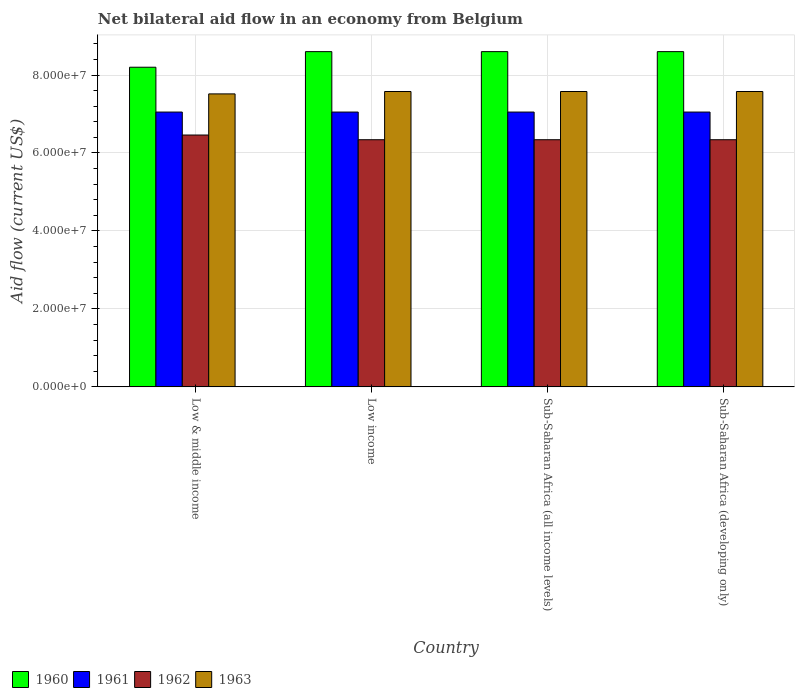Are the number of bars per tick equal to the number of legend labels?
Offer a terse response. Yes. How many bars are there on the 1st tick from the left?
Your answer should be compact. 4. What is the label of the 2nd group of bars from the left?
Keep it short and to the point. Low income. What is the net bilateral aid flow in 1962 in Sub-Saharan Africa (developing only)?
Provide a succinct answer. 6.34e+07. Across all countries, what is the maximum net bilateral aid flow in 1963?
Provide a short and direct response. 7.58e+07. Across all countries, what is the minimum net bilateral aid flow in 1963?
Offer a very short reply. 7.52e+07. What is the total net bilateral aid flow in 1963 in the graph?
Provide a succinct answer. 3.02e+08. What is the difference between the net bilateral aid flow in 1961 in Low & middle income and that in Sub-Saharan Africa (developing only)?
Provide a succinct answer. 0. What is the difference between the net bilateral aid flow in 1963 in Low income and the net bilateral aid flow in 1962 in Low & middle income?
Ensure brevity in your answer.  1.12e+07. What is the average net bilateral aid flow in 1960 per country?
Keep it short and to the point. 8.50e+07. What is the difference between the net bilateral aid flow of/in 1960 and net bilateral aid flow of/in 1961 in Sub-Saharan Africa (developing only)?
Give a very brief answer. 1.55e+07. In how many countries, is the net bilateral aid flow in 1963 greater than 68000000 US$?
Your answer should be very brief. 4. What is the ratio of the net bilateral aid flow in 1963 in Sub-Saharan Africa (all income levels) to that in Sub-Saharan Africa (developing only)?
Give a very brief answer. 1. Is the net bilateral aid flow in 1960 in Sub-Saharan Africa (all income levels) less than that in Sub-Saharan Africa (developing only)?
Your answer should be compact. No. What is the difference between the highest and the second highest net bilateral aid flow in 1962?
Your answer should be very brief. 1.21e+06. What is the difference between the highest and the lowest net bilateral aid flow in 1963?
Your response must be concise. 6.10e+05. In how many countries, is the net bilateral aid flow in 1962 greater than the average net bilateral aid flow in 1962 taken over all countries?
Offer a very short reply. 1. Is it the case that in every country, the sum of the net bilateral aid flow in 1962 and net bilateral aid flow in 1963 is greater than the sum of net bilateral aid flow in 1960 and net bilateral aid flow in 1961?
Keep it short and to the point. No. What does the 1st bar from the left in Low income represents?
Offer a very short reply. 1960. What does the 2nd bar from the right in Low & middle income represents?
Your response must be concise. 1962. How many bars are there?
Offer a very short reply. 16. Are all the bars in the graph horizontal?
Your response must be concise. No. What is the difference between two consecutive major ticks on the Y-axis?
Provide a short and direct response. 2.00e+07. Where does the legend appear in the graph?
Provide a succinct answer. Bottom left. What is the title of the graph?
Provide a succinct answer. Net bilateral aid flow in an economy from Belgium. What is the label or title of the X-axis?
Give a very brief answer. Country. What is the label or title of the Y-axis?
Ensure brevity in your answer.  Aid flow (current US$). What is the Aid flow (current US$) in 1960 in Low & middle income?
Your answer should be very brief. 8.20e+07. What is the Aid flow (current US$) of 1961 in Low & middle income?
Your answer should be compact. 7.05e+07. What is the Aid flow (current US$) of 1962 in Low & middle income?
Your answer should be very brief. 6.46e+07. What is the Aid flow (current US$) of 1963 in Low & middle income?
Ensure brevity in your answer.  7.52e+07. What is the Aid flow (current US$) in 1960 in Low income?
Your answer should be compact. 8.60e+07. What is the Aid flow (current US$) of 1961 in Low income?
Offer a terse response. 7.05e+07. What is the Aid flow (current US$) in 1962 in Low income?
Your answer should be compact. 6.34e+07. What is the Aid flow (current US$) of 1963 in Low income?
Provide a succinct answer. 7.58e+07. What is the Aid flow (current US$) in 1960 in Sub-Saharan Africa (all income levels)?
Keep it short and to the point. 8.60e+07. What is the Aid flow (current US$) in 1961 in Sub-Saharan Africa (all income levels)?
Keep it short and to the point. 7.05e+07. What is the Aid flow (current US$) in 1962 in Sub-Saharan Africa (all income levels)?
Your response must be concise. 6.34e+07. What is the Aid flow (current US$) of 1963 in Sub-Saharan Africa (all income levels)?
Offer a terse response. 7.58e+07. What is the Aid flow (current US$) in 1960 in Sub-Saharan Africa (developing only)?
Your response must be concise. 8.60e+07. What is the Aid flow (current US$) in 1961 in Sub-Saharan Africa (developing only)?
Your answer should be very brief. 7.05e+07. What is the Aid flow (current US$) of 1962 in Sub-Saharan Africa (developing only)?
Your answer should be very brief. 6.34e+07. What is the Aid flow (current US$) of 1963 in Sub-Saharan Africa (developing only)?
Make the answer very short. 7.58e+07. Across all countries, what is the maximum Aid flow (current US$) of 1960?
Keep it short and to the point. 8.60e+07. Across all countries, what is the maximum Aid flow (current US$) in 1961?
Offer a terse response. 7.05e+07. Across all countries, what is the maximum Aid flow (current US$) in 1962?
Your answer should be very brief. 6.46e+07. Across all countries, what is the maximum Aid flow (current US$) of 1963?
Your response must be concise. 7.58e+07. Across all countries, what is the minimum Aid flow (current US$) in 1960?
Make the answer very short. 8.20e+07. Across all countries, what is the minimum Aid flow (current US$) of 1961?
Offer a very short reply. 7.05e+07. Across all countries, what is the minimum Aid flow (current US$) in 1962?
Keep it short and to the point. 6.34e+07. Across all countries, what is the minimum Aid flow (current US$) in 1963?
Your response must be concise. 7.52e+07. What is the total Aid flow (current US$) of 1960 in the graph?
Give a very brief answer. 3.40e+08. What is the total Aid flow (current US$) of 1961 in the graph?
Ensure brevity in your answer.  2.82e+08. What is the total Aid flow (current US$) in 1962 in the graph?
Provide a succinct answer. 2.55e+08. What is the total Aid flow (current US$) of 1963 in the graph?
Ensure brevity in your answer.  3.02e+08. What is the difference between the Aid flow (current US$) in 1960 in Low & middle income and that in Low income?
Your answer should be very brief. -4.00e+06. What is the difference between the Aid flow (current US$) in 1961 in Low & middle income and that in Low income?
Keep it short and to the point. 0. What is the difference between the Aid flow (current US$) of 1962 in Low & middle income and that in Low income?
Provide a short and direct response. 1.21e+06. What is the difference between the Aid flow (current US$) of 1963 in Low & middle income and that in Low income?
Provide a succinct answer. -6.10e+05. What is the difference between the Aid flow (current US$) of 1960 in Low & middle income and that in Sub-Saharan Africa (all income levels)?
Your response must be concise. -4.00e+06. What is the difference between the Aid flow (current US$) in 1962 in Low & middle income and that in Sub-Saharan Africa (all income levels)?
Make the answer very short. 1.21e+06. What is the difference between the Aid flow (current US$) of 1963 in Low & middle income and that in Sub-Saharan Africa (all income levels)?
Offer a very short reply. -6.10e+05. What is the difference between the Aid flow (current US$) in 1962 in Low & middle income and that in Sub-Saharan Africa (developing only)?
Your response must be concise. 1.21e+06. What is the difference between the Aid flow (current US$) in 1963 in Low & middle income and that in Sub-Saharan Africa (developing only)?
Ensure brevity in your answer.  -6.10e+05. What is the difference between the Aid flow (current US$) in 1960 in Low income and that in Sub-Saharan Africa (all income levels)?
Your response must be concise. 0. What is the difference between the Aid flow (current US$) in 1963 in Low income and that in Sub-Saharan Africa (all income levels)?
Your answer should be compact. 0. What is the difference between the Aid flow (current US$) of 1960 in Low income and that in Sub-Saharan Africa (developing only)?
Keep it short and to the point. 0. What is the difference between the Aid flow (current US$) in 1961 in Low income and that in Sub-Saharan Africa (developing only)?
Make the answer very short. 0. What is the difference between the Aid flow (current US$) of 1961 in Sub-Saharan Africa (all income levels) and that in Sub-Saharan Africa (developing only)?
Offer a very short reply. 0. What is the difference between the Aid flow (current US$) in 1960 in Low & middle income and the Aid flow (current US$) in 1961 in Low income?
Your answer should be very brief. 1.15e+07. What is the difference between the Aid flow (current US$) in 1960 in Low & middle income and the Aid flow (current US$) in 1962 in Low income?
Your answer should be very brief. 1.86e+07. What is the difference between the Aid flow (current US$) of 1960 in Low & middle income and the Aid flow (current US$) of 1963 in Low income?
Offer a terse response. 6.23e+06. What is the difference between the Aid flow (current US$) of 1961 in Low & middle income and the Aid flow (current US$) of 1962 in Low income?
Provide a succinct answer. 7.10e+06. What is the difference between the Aid flow (current US$) in 1961 in Low & middle income and the Aid flow (current US$) in 1963 in Low income?
Your answer should be compact. -5.27e+06. What is the difference between the Aid flow (current US$) of 1962 in Low & middle income and the Aid flow (current US$) of 1963 in Low income?
Your answer should be very brief. -1.12e+07. What is the difference between the Aid flow (current US$) in 1960 in Low & middle income and the Aid flow (current US$) in 1961 in Sub-Saharan Africa (all income levels)?
Make the answer very short. 1.15e+07. What is the difference between the Aid flow (current US$) in 1960 in Low & middle income and the Aid flow (current US$) in 1962 in Sub-Saharan Africa (all income levels)?
Make the answer very short. 1.86e+07. What is the difference between the Aid flow (current US$) in 1960 in Low & middle income and the Aid flow (current US$) in 1963 in Sub-Saharan Africa (all income levels)?
Offer a very short reply. 6.23e+06. What is the difference between the Aid flow (current US$) of 1961 in Low & middle income and the Aid flow (current US$) of 1962 in Sub-Saharan Africa (all income levels)?
Your response must be concise. 7.10e+06. What is the difference between the Aid flow (current US$) in 1961 in Low & middle income and the Aid flow (current US$) in 1963 in Sub-Saharan Africa (all income levels)?
Keep it short and to the point. -5.27e+06. What is the difference between the Aid flow (current US$) in 1962 in Low & middle income and the Aid flow (current US$) in 1963 in Sub-Saharan Africa (all income levels)?
Offer a very short reply. -1.12e+07. What is the difference between the Aid flow (current US$) of 1960 in Low & middle income and the Aid flow (current US$) of 1961 in Sub-Saharan Africa (developing only)?
Your answer should be very brief. 1.15e+07. What is the difference between the Aid flow (current US$) in 1960 in Low & middle income and the Aid flow (current US$) in 1962 in Sub-Saharan Africa (developing only)?
Provide a short and direct response. 1.86e+07. What is the difference between the Aid flow (current US$) of 1960 in Low & middle income and the Aid flow (current US$) of 1963 in Sub-Saharan Africa (developing only)?
Give a very brief answer. 6.23e+06. What is the difference between the Aid flow (current US$) of 1961 in Low & middle income and the Aid flow (current US$) of 1962 in Sub-Saharan Africa (developing only)?
Give a very brief answer. 7.10e+06. What is the difference between the Aid flow (current US$) in 1961 in Low & middle income and the Aid flow (current US$) in 1963 in Sub-Saharan Africa (developing only)?
Offer a very short reply. -5.27e+06. What is the difference between the Aid flow (current US$) of 1962 in Low & middle income and the Aid flow (current US$) of 1963 in Sub-Saharan Africa (developing only)?
Offer a terse response. -1.12e+07. What is the difference between the Aid flow (current US$) in 1960 in Low income and the Aid flow (current US$) in 1961 in Sub-Saharan Africa (all income levels)?
Make the answer very short. 1.55e+07. What is the difference between the Aid flow (current US$) in 1960 in Low income and the Aid flow (current US$) in 1962 in Sub-Saharan Africa (all income levels)?
Provide a succinct answer. 2.26e+07. What is the difference between the Aid flow (current US$) of 1960 in Low income and the Aid flow (current US$) of 1963 in Sub-Saharan Africa (all income levels)?
Provide a succinct answer. 1.02e+07. What is the difference between the Aid flow (current US$) in 1961 in Low income and the Aid flow (current US$) in 1962 in Sub-Saharan Africa (all income levels)?
Offer a terse response. 7.10e+06. What is the difference between the Aid flow (current US$) of 1961 in Low income and the Aid flow (current US$) of 1963 in Sub-Saharan Africa (all income levels)?
Make the answer very short. -5.27e+06. What is the difference between the Aid flow (current US$) in 1962 in Low income and the Aid flow (current US$) in 1963 in Sub-Saharan Africa (all income levels)?
Your response must be concise. -1.24e+07. What is the difference between the Aid flow (current US$) of 1960 in Low income and the Aid flow (current US$) of 1961 in Sub-Saharan Africa (developing only)?
Make the answer very short. 1.55e+07. What is the difference between the Aid flow (current US$) in 1960 in Low income and the Aid flow (current US$) in 1962 in Sub-Saharan Africa (developing only)?
Your response must be concise. 2.26e+07. What is the difference between the Aid flow (current US$) in 1960 in Low income and the Aid flow (current US$) in 1963 in Sub-Saharan Africa (developing only)?
Provide a succinct answer. 1.02e+07. What is the difference between the Aid flow (current US$) of 1961 in Low income and the Aid flow (current US$) of 1962 in Sub-Saharan Africa (developing only)?
Offer a very short reply. 7.10e+06. What is the difference between the Aid flow (current US$) of 1961 in Low income and the Aid flow (current US$) of 1963 in Sub-Saharan Africa (developing only)?
Your answer should be very brief. -5.27e+06. What is the difference between the Aid flow (current US$) of 1962 in Low income and the Aid flow (current US$) of 1963 in Sub-Saharan Africa (developing only)?
Your answer should be compact. -1.24e+07. What is the difference between the Aid flow (current US$) of 1960 in Sub-Saharan Africa (all income levels) and the Aid flow (current US$) of 1961 in Sub-Saharan Africa (developing only)?
Provide a short and direct response. 1.55e+07. What is the difference between the Aid flow (current US$) of 1960 in Sub-Saharan Africa (all income levels) and the Aid flow (current US$) of 1962 in Sub-Saharan Africa (developing only)?
Give a very brief answer. 2.26e+07. What is the difference between the Aid flow (current US$) of 1960 in Sub-Saharan Africa (all income levels) and the Aid flow (current US$) of 1963 in Sub-Saharan Africa (developing only)?
Make the answer very short. 1.02e+07. What is the difference between the Aid flow (current US$) of 1961 in Sub-Saharan Africa (all income levels) and the Aid flow (current US$) of 1962 in Sub-Saharan Africa (developing only)?
Your response must be concise. 7.10e+06. What is the difference between the Aid flow (current US$) in 1961 in Sub-Saharan Africa (all income levels) and the Aid flow (current US$) in 1963 in Sub-Saharan Africa (developing only)?
Keep it short and to the point. -5.27e+06. What is the difference between the Aid flow (current US$) of 1962 in Sub-Saharan Africa (all income levels) and the Aid flow (current US$) of 1963 in Sub-Saharan Africa (developing only)?
Your answer should be compact. -1.24e+07. What is the average Aid flow (current US$) in 1960 per country?
Your response must be concise. 8.50e+07. What is the average Aid flow (current US$) of 1961 per country?
Offer a terse response. 7.05e+07. What is the average Aid flow (current US$) in 1962 per country?
Provide a short and direct response. 6.37e+07. What is the average Aid flow (current US$) in 1963 per country?
Give a very brief answer. 7.56e+07. What is the difference between the Aid flow (current US$) in 1960 and Aid flow (current US$) in 1961 in Low & middle income?
Ensure brevity in your answer.  1.15e+07. What is the difference between the Aid flow (current US$) in 1960 and Aid flow (current US$) in 1962 in Low & middle income?
Ensure brevity in your answer.  1.74e+07. What is the difference between the Aid flow (current US$) in 1960 and Aid flow (current US$) in 1963 in Low & middle income?
Keep it short and to the point. 6.84e+06. What is the difference between the Aid flow (current US$) of 1961 and Aid flow (current US$) of 1962 in Low & middle income?
Give a very brief answer. 5.89e+06. What is the difference between the Aid flow (current US$) of 1961 and Aid flow (current US$) of 1963 in Low & middle income?
Ensure brevity in your answer.  -4.66e+06. What is the difference between the Aid flow (current US$) of 1962 and Aid flow (current US$) of 1963 in Low & middle income?
Offer a very short reply. -1.06e+07. What is the difference between the Aid flow (current US$) in 1960 and Aid flow (current US$) in 1961 in Low income?
Make the answer very short. 1.55e+07. What is the difference between the Aid flow (current US$) in 1960 and Aid flow (current US$) in 1962 in Low income?
Ensure brevity in your answer.  2.26e+07. What is the difference between the Aid flow (current US$) in 1960 and Aid flow (current US$) in 1963 in Low income?
Your answer should be compact. 1.02e+07. What is the difference between the Aid flow (current US$) of 1961 and Aid flow (current US$) of 1962 in Low income?
Make the answer very short. 7.10e+06. What is the difference between the Aid flow (current US$) of 1961 and Aid flow (current US$) of 1963 in Low income?
Offer a very short reply. -5.27e+06. What is the difference between the Aid flow (current US$) of 1962 and Aid flow (current US$) of 1963 in Low income?
Provide a short and direct response. -1.24e+07. What is the difference between the Aid flow (current US$) of 1960 and Aid flow (current US$) of 1961 in Sub-Saharan Africa (all income levels)?
Keep it short and to the point. 1.55e+07. What is the difference between the Aid flow (current US$) of 1960 and Aid flow (current US$) of 1962 in Sub-Saharan Africa (all income levels)?
Offer a very short reply. 2.26e+07. What is the difference between the Aid flow (current US$) in 1960 and Aid flow (current US$) in 1963 in Sub-Saharan Africa (all income levels)?
Ensure brevity in your answer.  1.02e+07. What is the difference between the Aid flow (current US$) in 1961 and Aid flow (current US$) in 1962 in Sub-Saharan Africa (all income levels)?
Keep it short and to the point. 7.10e+06. What is the difference between the Aid flow (current US$) of 1961 and Aid flow (current US$) of 1963 in Sub-Saharan Africa (all income levels)?
Your response must be concise. -5.27e+06. What is the difference between the Aid flow (current US$) in 1962 and Aid flow (current US$) in 1963 in Sub-Saharan Africa (all income levels)?
Your answer should be very brief. -1.24e+07. What is the difference between the Aid flow (current US$) in 1960 and Aid flow (current US$) in 1961 in Sub-Saharan Africa (developing only)?
Give a very brief answer. 1.55e+07. What is the difference between the Aid flow (current US$) in 1960 and Aid flow (current US$) in 1962 in Sub-Saharan Africa (developing only)?
Provide a succinct answer. 2.26e+07. What is the difference between the Aid flow (current US$) in 1960 and Aid flow (current US$) in 1963 in Sub-Saharan Africa (developing only)?
Provide a short and direct response. 1.02e+07. What is the difference between the Aid flow (current US$) of 1961 and Aid flow (current US$) of 1962 in Sub-Saharan Africa (developing only)?
Your answer should be very brief. 7.10e+06. What is the difference between the Aid flow (current US$) in 1961 and Aid flow (current US$) in 1963 in Sub-Saharan Africa (developing only)?
Offer a terse response. -5.27e+06. What is the difference between the Aid flow (current US$) in 1962 and Aid flow (current US$) in 1963 in Sub-Saharan Africa (developing only)?
Keep it short and to the point. -1.24e+07. What is the ratio of the Aid flow (current US$) of 1960 in Low & middle income to that in Low income?
Offer a very short reply. 0.95. What is the ratio of the Aid flow (current US$) in 1961 in Low & middle income to that in Low income?
Give a very brief answer. 1. What is the ratio of the Aid flow (current US$) in 1962 in Low & middle income to that in Low income?
Give a very brief answer. 1.02. What is the ratio of the Aid flow (current US$) of 1960 in Low & middle income to that in Sub-Saharan Africa (all income levels)?
Your response must be concise. 0.95. What is the ratio of the Aid flow (current US$) in 1961 in Low & middle income to that in Sub-Saharan Africa (all income levels)?
Give a very brief answer. 1. What is the ratio of the Aid flow (current US$) in 1962 in Low & middle income to that in Sub-Saharan Africa (all income levels)?
Provide a succinct answer. 1.02. What is the ratio of the Aid flow (current US$) of 1960 in Low & middle income to that in Sub-Saharan Africa (developing only)?
Offer a very short reply. 0.95. What is the ratio of the Aid flow (current US$) of 1961 in Low & middle income to that in Sub-Saharan Africa (developing only)?
Your answer should be very brief. 1. What is the ratio of the Aid flow (current US$) in 1962 in Low & middle income to that in Sub-Saharan Africa (developing only)?
Offer a terse response. 1.02. What is the ratio of the Aid flow (current US$) in 1961 in Low income to that in Sub-Saharan Africa (all income levels)?
Your answer should be very brief. 1. What is the ratio of the Aid flow (current US$) of 1962 in Low income to that in Sub-Saharan Africa (all income levels)?
Give a very brief answer. 1. What is the ratio of the Aid flow (current US$) of 1961 in Low income to that in Sub-Saharan Africa (developing only)?
Your answer should be very brief. 1. What is the ratio of the Aid flow (current US$) of 1963 in Low income to that in Sub-Saharan Africa (developing only)?
Offer a very short reply. 1. What is the ratio of the Aid flow (current US$) of 1960 in Sub-Saharan Africa (all income levels) to that in Sub-Saharan Africa (developing only)?
Your answer should be very brief. 1. What is the ratio of the Aid flow (current US$) in 1961 in Sub-Saharan Africa (all income levels) to that in Sub-Saharan Africa (developing only)?
Provide a succinct answer. 1. What is the ratio of the Aid flow (current US$) in 1962 in Sub-Saharan Africa (all income levels) to that in Sub-Saharan Africa (developing only)?
Offer a very short reply. 1. What is the difference between the highest and the second highest Aid flow (current US$) in 1960?
Make the answer very short. 0. What is the difference between the highest and the second highest Aid flow (current US$) of 1962?
Your answer should be very brief. 1.21e+06. What is the difference between the highest and the second highest Aid flow (current US$) in 1963?
Offer a terse response. 0. What is the difference between the highest and the lowest Aid flow (current US$) of 1960?
Offer a very short reply. 4.00e+06. What is the difference between the highest and the lowest Aid flow (current US$) in 1962?
Your answer should be compact. 1.21e+06. What is the difference between the highest and the lowest Aid flow (current US$) in 1963?
Provide a short and direct response. 6.10e+05. 